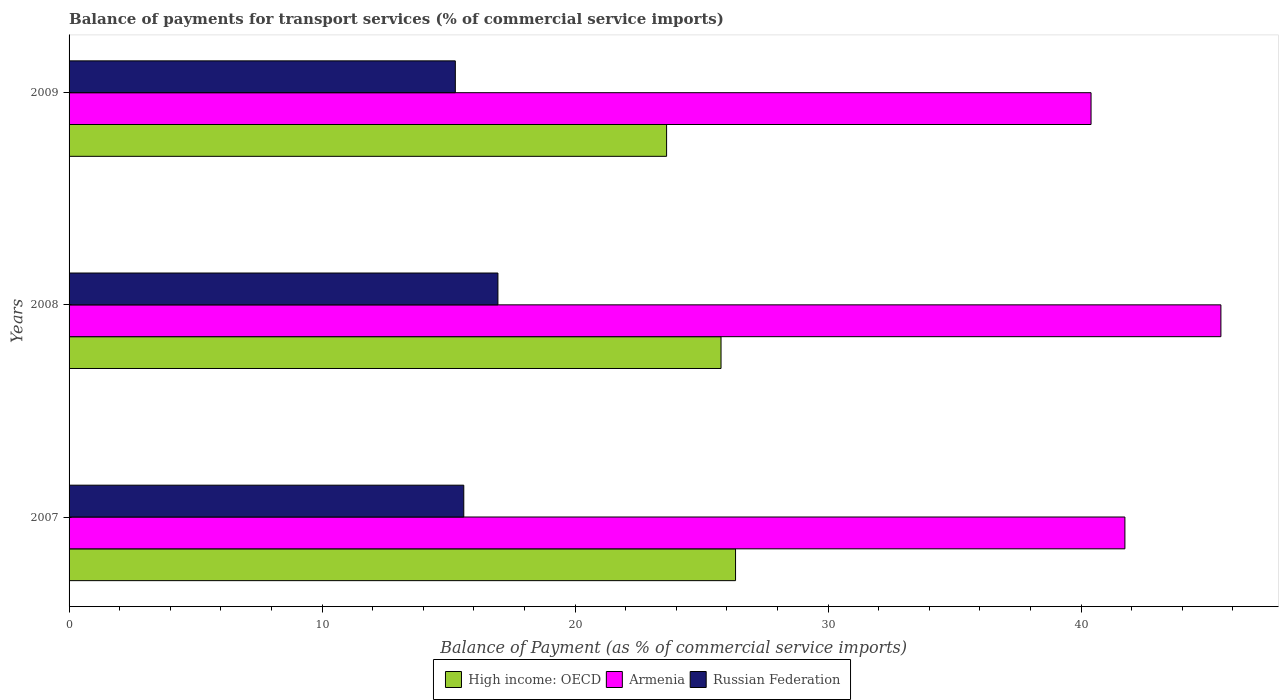How many groups of bars are there?
Provide a short and direct response. 3. Are the number of bars per tick equal to the number of legend labels?
Provide a succinct answer. Yes. Are the number of bars on each tick of the Y-axis equal?
Offer a very short reply. Yes. What is the label of the 2nd group of bars from the top?
Offer a terse response. 2008. In how many cases, is the number of bars for a given year not equal to the number of legend labels?
Make the answer very short. 0. What is the balance of payments for transport services in Russian Federation in 2008?
Keep it short and to the point. 16.95. Across all years, what is the maximum balance of payments for transport services in Armenia?
Offer a terse response. 45.52. Across all years, what is the minimum balance of payments for transport services in High income: OECD?
Provide a succinct answer. 23.62. In which year was the balance of payments for transport services in High income: OECD maximum?
Offer a terse response. 2007. In which year was the balance of payments for transport services in Armenia minimum?
Offer a terse response. 2009. What is the total balance of payments for transport services in Russian Federation in the graph?
Your answer should be compact. 47.82. What is the difference between the balance of payments for transport services in Russian Federation in 2008 and that in 2009?
Keep it short and to the point. 1.68. What is the difference between the balance of payments for transport services in Russian Federation in 2009 and the balance of payments for transport services in High income: OECD in 2007?
Ensure brevity in your answer.  -11.08. What is the average balance of payments for transport services in High income: OECD per year?
Your answer should be compact. 25.24. In the year 2007, what is the difference between the balance of payments for transport services in Armenia and balance of payments for transport services in Russian Federation?
Your response must be concise. 26.13. What is the ratio of the balance of payments for transport services in High income: OECD in 2007 to that in 2008?
Your answer should be compact. 1.02. What is the difference between the highest and the second highest balance of payments for transport services in Russian Federation?
Your answer should be compact. 1.35. What is the difference between the highest and the lowest balance of payments for transport services in High income: OECD?
Offer a very short reply. 2.73. What does the 3rd bar from the top in 2009 represents?
Your answer should be very brief. High income: OECD. What does the 2nd bar from the bottom in 2008 represents?
Ensure brevity in your answer.  Armenia. Is it the case that in every year, the sum of the balance of payments for transport services in Russian Federation and balance of payments for transport services in High income: OECD is greater than the balance of payments for transport services in Armenia?
Make the answer very short. No. How many years are there in the graph?
Provide a succinct answer. 3. What is the difference between two consecutive major ticks on the X-axis?
Offer a terse response. 10. Are the values on the major ticks of X-axis written in scientific E-notation?
Ensure brevity in your answer.  No. Where does the legend appear in the graph?
Your response must be concise. Bottom center. What is the title of the graph?
Give a very brief answer. Balance of payments for transport services (% of commercial service imports). Does "Belarus" appear as one of the legend labels in the graph?
Keep it short and to the point. No. What is the label or title of the X-axis?
Your response must be concise. Balance of Payment (as % of commercial service imports). What is the Balance of Payment (as % of commercial service imports) of High income: OECD in 2007?
Make the answer very short. 26.34. What is the Balance of Payment (as % of commercial service imports) in Armenia in 2007?
Provide a succinct answer. 41.73. What is the Balance of Payment (as % of commercial service imports) of Russian Federation in 2007?
Offer a terse response. 15.6. What is the Balance of Payment (as % of commercial service imports) in High income: OECD in 2008?
Provide a short and direct response. 25.77. What is the Balance of Payment (as % of commercial service imports) in Armenia in 2008?
Your answer should be compact. 45.52. What is the Balance of Payment (as % of commercial service imports) in Russian Federation in 2008?
Offer a very short reply. 16.95. What is the Balance of Payment (as % of commercial service imports) of High income: OECD in 2009?
Ensure brevity in your answer.  23.62. What is the Balance of Payment (as % of commercial service imports) of Armenia in 2009?
Your answer should be compact. 40.39. What is the Balance of Payment (as % of commercial service imports) of Russian Federation in 2009?
Your answer should be compact. 15.27. Across all years, what is the maximum Balance of Payment (as % of commercial service imports) of High income: OECD?
Make the answer very short. 26.34. Across all years, what is the maximum Balance of Payment (as % of commercial service imports) of Armenia?
Provide a short and direct response. 45.52. Across all years, what is the maximum Balance of Payment (as % of commercial service imports) of Russian Federation?
Ensure brevity in your answer.  16.95. Across all years, what is the minimum Balance of Payment (as % of commercial service imports) of High income: OECD?
Provide a short and direct response. 23.62. Across all years, what is the minimum Balance of Payment (as % of commercial service imports) in Armenia?
Your answer should be compact. 40.39. Across all years, what is the minimum Balance of Payment (as % of commercial service imports) of Russian Federation?
Provide a succinct answer. 15.27. What is the total Balance of Payment (as % of commercial service imports) in High income: OECD in the graph?
Your answer should be very brief. 75.72. What is the total Balance of Payment (as % of commercial service imports) of Armenia in the graph?
Provide a succinct answer. 127.64. What is the total Balance of Payment (as % of commercial service imports) of Russian Federation in the graph?
Your response must be concise. 47.82. What is the difference between the Balance of Payment (as % of commercial service imports) of High income: OECD in 2007 and that in 2008?
Offer a terse response. 0.57. What is the difference between the Balance of Payment (as % of commercial service imports) in Armenia in 2007 and that in 2008?
Make the answer very short. -3.79. What is the difference between the Balance of Payment (as % of commercial service imports) in Russian Federation in 2007 and that in 2008?
Make the answer very short. -1.35. What is the difference between the Balance of Payment (as % of commercial service imports) in High income: OECD in 2007 and that in 2009?
Provide a short and direct response. 2.73. What is the difference between the Balance of Payment (as % of commercial service imports) in Armenia in 2007 and that in 2009?
Your answer should be very brief. 1.34. What is the difference between the Balance of Payment (as % of commercial service imports) of Russian Federation in 2007 and that in 2009?
Keep it short and to the point. 0.33. What is the difference between the Balance of Payment (as % of commercial service imports) in High income: OECD in 2008 and that in 2009?
Ensure brevity in your answer.  2.15. What is the difference between the Balance of Payment (as % of commercial service imports) of Armenia in 2008 and that in 2009?
Your answer should be very brief. 5.13. What is the difference between the Balance of Payment (as % of commercial service imports) of Russian Federation in 2008 and that in 2009?
Make the answer very short. 1.68. What is the difference between the Balance of Payment (as % of commercial service imports) of High income: OECD in 2007 and the Balance of Payment (as % of commercial service imports) of Armenia in 2008?
Make the answer very short. -19.18. What is the difference between the Balance of Payment (as % of commercial service imports) of High income: OECD in 2007 and the Balance of Payment (as % of commercial service imports) of Russian Federation in 2008?
Give a very brief answer. 9.39. What is the difference between the Balance of Payment (as % of commercial service imports) in Armenia in 2007 and the Balance of Payment (as % of commercial service imports) in Russian Federation in 2008?
Ensure brevity in your answer.  24.78. What is the difference between the Balance of Payment (as % of commercial service imports) of High income: OECD in 2007 and the Balance of Payment (as % of commercial service imports) of Armenia in 2009?
Ensure brevity in your answer.  -14.05. What is the difference between the Balance of Payment (as % of commercial service imports) of High income: OECD in 2007 and the Balance of Payment (as % of commercial service imports) of Russian Federation in 2009?
Provide a succinct answer. 11.08. What is the difference between the Balance of Payment (as % of commercial service imports) in Armenia in 2007 and the Balance of Payment (as % of commercial service imports) in Russian Federation in 2009?
Give a very brief answer. 26.46. What is the difference between the Balance of Payment (as % of commercial service imports) in High income: OECD in 2008 and the Balance of Payment (as % of commercial service imports) in Armenia in 2009?
Your response must be concise. -14.62. What is the difference between the Balance of Payment (as % of commercial service imports) of High income: OECD in 2008 and the Balance of Payment (as % of commercial service imports) of Russian Federation in 2009?
Give a very brief answer. 10.5. What is the difference between the Balance of Payment (as % of commercial service imports) of Armenia in 2008 and the Balance of Payment (as % of commercial service imports) of Russian Federation in 2009?
Provide a short and direct response. 30.26. What is the average Balance of Payment (as % of commercial service imports) in High income: OECD per year?
Your answer should be very brief. 25.24. What is the average Balance of Payment (as % of commercial service imports) of Armenia per year?
Make the answer very short. 42.55. What is the average Balance of Payment (as % of commercial service imports) in Russian Federation per year?
Your response must be concise. 15.94. In the year 2007, what is the difference between the Balance of Payment (as % of commercial service imports) in High income: OECD and Balance of Payment (as % of commercial service imports) in Armenia?
Give a very brief answer. -15.39. In the year 2007, what is the difference between the Balance of Payment (as % of commercial service imports) of High income: OECD and Balance of Payment (as % of commercial service imports) of Russian Federation?
Keep it short and to the point. 10.74. In the year 2007, what is the difference between the Balance of Payment (as % of commercial service imports) in Armenia and Balance of Payment (as % of commercial service imports) in Russian Federation?
Keep it short and to the point. 26.13. In the year 2008, what is the difference between the Balance of Payment (as % of commercial service imports) of High income: OECD and Balance of Payment (as % of commercial service imports) of Armenia?
Keep it short and to the point. -19.76. In the year 2008, what is the difference between the Balance of Payment (as % of commercial service imports) of High income: OECD and Balance of Payment (as % of commercial service imports) of Russian Federation?
Your answer should be very brief. 8.82. In the year 2008, what is the difference between the Balance of Payment (as % of commercial service imports) of Armenia and Balance of Payment (as % of commercial service imports) of Russian Federation?
Keep it short and to the point. 28.57. In the year 2009, what is the difference between the Balance of Payment (as % of commercial service imports) in High income: OECD and Balance of Payment (as % of commercial service imports) in Armenia?
Give a very brief answer. -16.78. In the year 2009, what is the difference between the Balance of Payment (as % of commercial service imports) in High income: OECD and Balance of Payment (as % of commercial service imports) in Russian Federation?
Make the answer very short. 8.35. In the year 2009, what is the difference between the Balance of Payment (as % of commercial service imports) in Armenia and Balance of Payment (as % of commercial service imports) in Russian Federation?
Your answer should be compact. 25.13. What is the ratio of the Balance of Payment (as % of commercial service imports) of High income: OECD in 2007 to that in 2008?
Keep it short and to the point. 1.02. What is the ratio of the Balance of Payment (as % of commercial service imports) in Armenia in 2007 to that in 2008?
Offer a very short reply. 0.92. What is the ratio of the Balance of Payment (as % of commercial service imports) of Russian Federation in 2007 to that in 2008?
Offer a terse response. 0.92. What is the ratio of the Balance of Payment (as % of commercial service imports) of High income: OECD in 2007 to that in 2009?
Keep it short and to the point. 1.12. What is the ratio of the Balance of Payment (as % of commercial service imports) of Armenia in 2007 to that in 2009?
Your response must be concise. 1.03. What is the ratio of the Balance of Payment (as % of commercial service imports) in Russian Federation in 2007 to that in 2009?
Your answer should be compact. 1.02. What is the ratio of the Balance of Payment (as % of commercial service imports) of High income: OECD in 2008 to that in 2009?
Make the answer very short. 1.09. What is the ratio of the Balance of Payment (as % of commercial service imports) of Armenia in 2008 to that in 2009?
Offer a very short reply. 1.13. What is the ratio of the Balance of Payment (as % of commercial service imports) of Russian Federation in 2008 to that in 2009?
Keep it short and to the point. 1.11. What is the difference between the highest and the second highest Balance of Payment (as % of commercial service imports) in High income: OECD?
Keep it short and to the point. 0.57. What is the difference between the highest and the second highest Balance of Payment (as % of commercial service imports) of Armenia?
Keep it short and to the point. 3.79. What is the difference between the highest and the second highest Balance of Payment (as % of commercial service imports) in Russian Federation?
Offer a very short reply. 1.35. What is the difference between the highest and the lowest Balance of Payment (as % of commercial service imports) of High income: OECD?
Ensure brevity in your answer.  2.73. What is the difference between the highest and the lowest Balance of Payment (as % of commercial service imports) in Armenia?
Provide a short and direct response. 5.13. What is the difference between the highest and the lowest Balance of Payment (as % of commercial service imports) of Russian Federation?
Offer a very short reply. 1.68. 